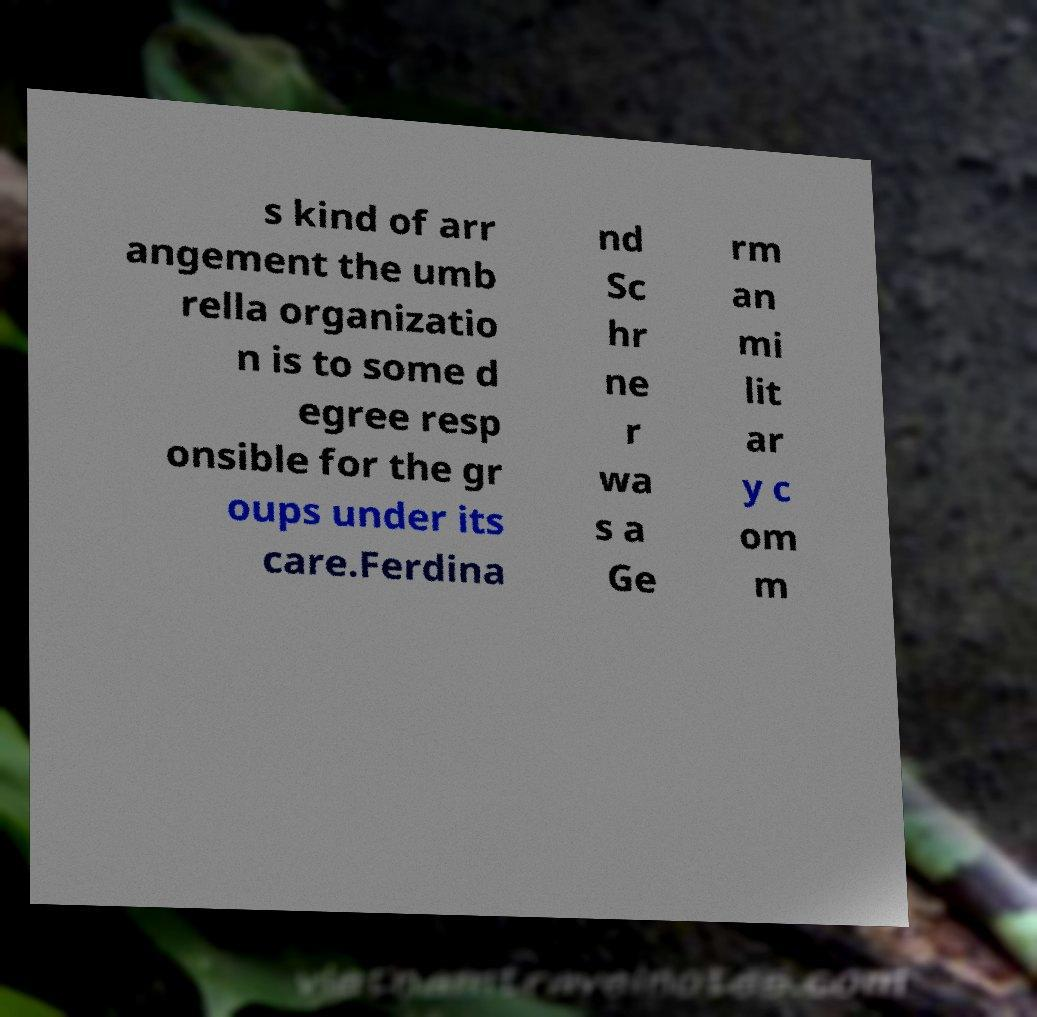Could you assist in decoding the text presented in this image and type it out clearly? s kind of arr angement the umb rella organizatio n is to some d egree resp onsible for the gr oups under its care.Ferdina nd Sc hr ne r wa s a Ge rm an mi lit ar y c om m 